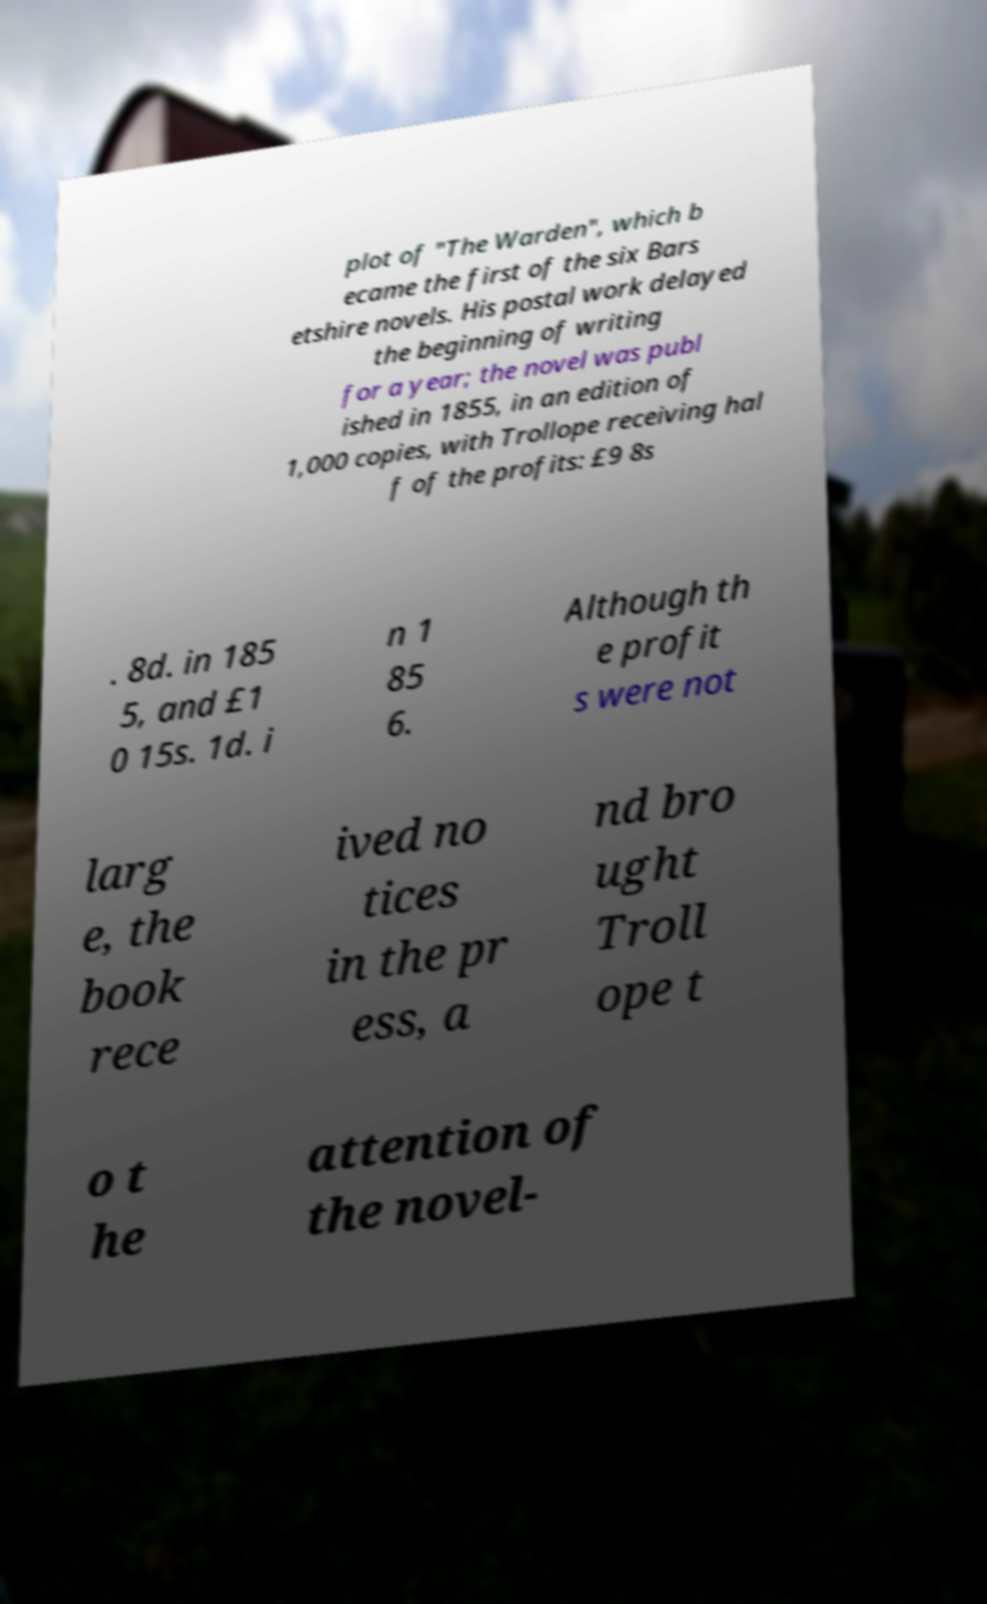What messages or text are displayed in this image? I need them in a readable, typed format. plot of "The Warden", which b ecame the first of the six Bars etshire novels. His postal work delayed the beginning of writing for a year; the novel was publ ished in 1855, in an edition of 1,000 copies, with Trollope receiving hal f of the profits: £9 8s . 8d. in 185 5, and £1 0 15s. 1d. i n 1 85 6. Although th e profit s were not larg e, the book rece ived no tices in the pr ess, a nd bro ught Troll ope t o t he attention of the novel- 